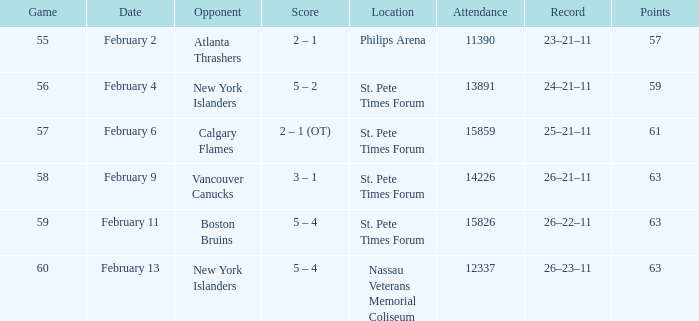What outcomes took place on february 9? 3 – 1. 